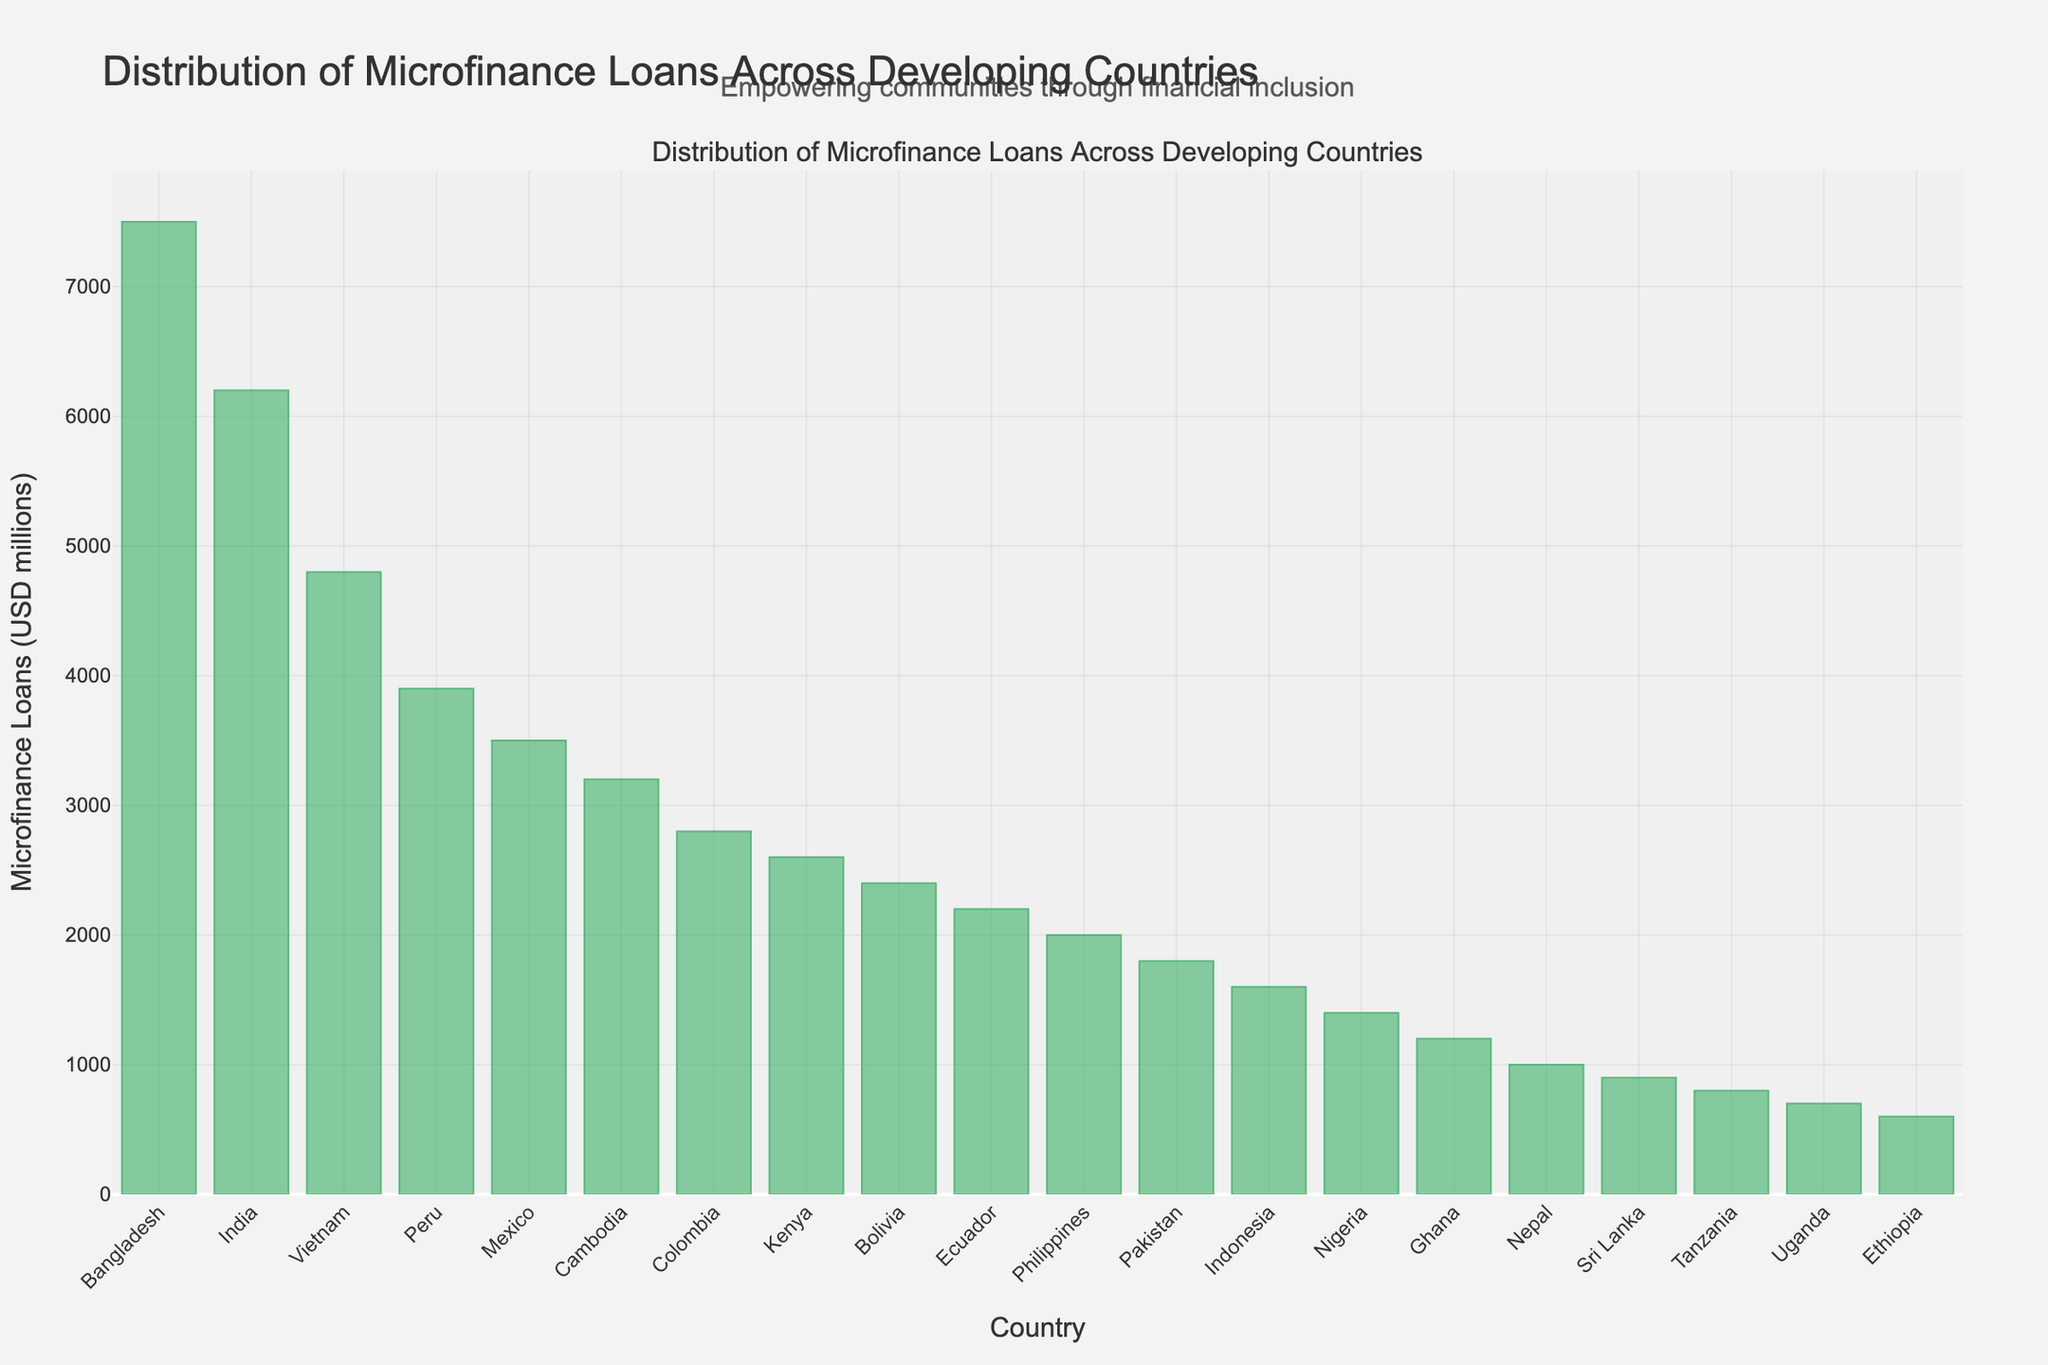What's the country with the highest amount of microfinance loans? Identify the country with the tallest bar in the bar chart. The tallest bar represents Bangladesh with 7500 million USD in microfinance loans.
Answer: Bangladesh How much more microfinance loan does Bangladesh have compared to Kenya? Find the microfinance loan amounts for both countries (7500 for Bangladesh and 2600 for Kenya) and subtract Kenya's amount from Bangladesh's amount. 7500 - 2600 = 4900.
Answer: 4900 Which country has the smallest amount of microfinance loans? Identify the country with the shortest bar in the bar chart. The shortest bar represents Ethiopia with 600 million USD in microfinance loans.
Answer: Ethiopia What is the combined microfinance loan amount for the top three countries? Add the microfinance loan amounts for the top three countries: Bangladesh (7500), India (6200), and Vietnam (4800). 7500 + 6200 + 4800 = 18500 million USD.
Answer: 18500 Which countries have microfinance loans less than 3000 million USD but more than 1500 million USD? Identify the countries with bars representing amounts between 1500 and 3000 million USD: Colombia (2800), Kenya (2600), Bolivia (2400), and Ecuador (2200).
Answer: Colombia, Kenya, Bolivia, Ecuador What is the average microfinance loan amount for the bottom five countries? Add the microfinance loan amounts for the bottom five countries: Pakistan (1800), Indonesia (1600), Nigeria (1400), Ghana (1200), and Nepal (1000). Sum is 1800 + 1600 + 1400 + 1200 + 1000 = 7000. Then, divide by 5. 7000 / 5 = 1400 million USD.
Answer: 1400 How many countries have microfinance loan amounts greater than 3000 million USD? Count the number of countries with bars representing values over 3000 million USD: Bangladesh, India, Vietnam, Peru, Mexico, and Cambodia. There are 6 such countries.
Answer: 6 Which is the only African country on the higher end of microfinance loans in this chart? Identify the only African country with a relatively high loan amount compared to others on the chart. Kenya is this country with 2600 million USD.
Answer: Kenya Are there any two countries with exactly equal amounts of microfinance loans? Analyze the bars to see if any two bars are of equal height. No two countries have bars of equal height in the chart.
Answer: No What is the total amount of microfinance loans distributed in Asian countries from the chart? Add up the microfinance loan amounts for the Asian countries: Bangladesh (7500), India (6200), Vietnam (4800), Cambodia (3200), Pakistan (1800), Indonesia (1600), Sri Lanka (900), Nepal (1000) = 7500 + 6200 + 4800 + 3200 + 1800 + 1600 + 900 + 1000 = 27000 million USD.
Answer: 27000 